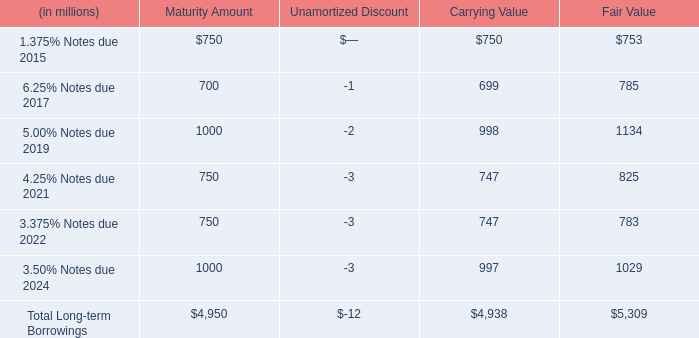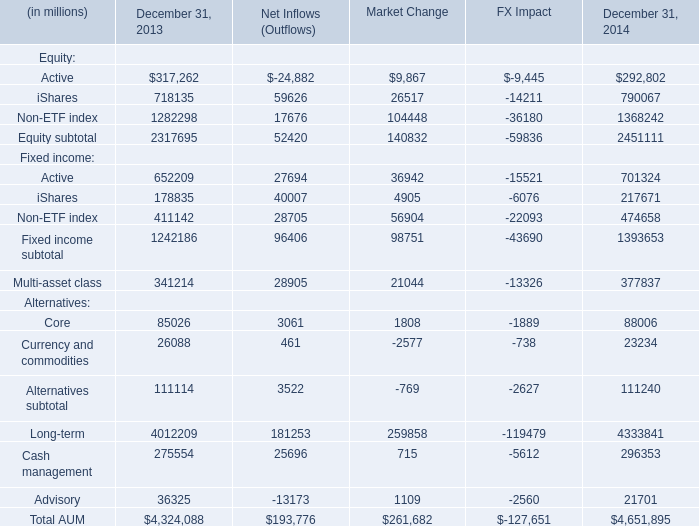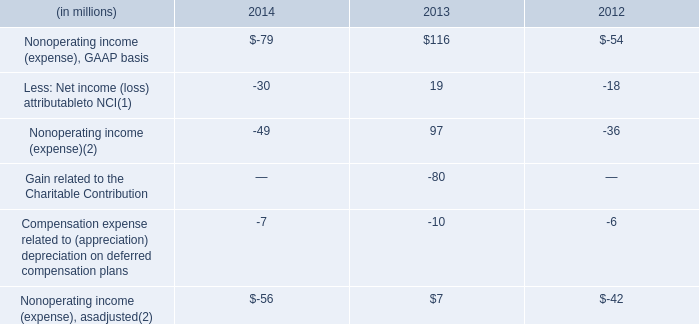In what year is equity subtotal greater than 2450000? 
Answer: 2014. 